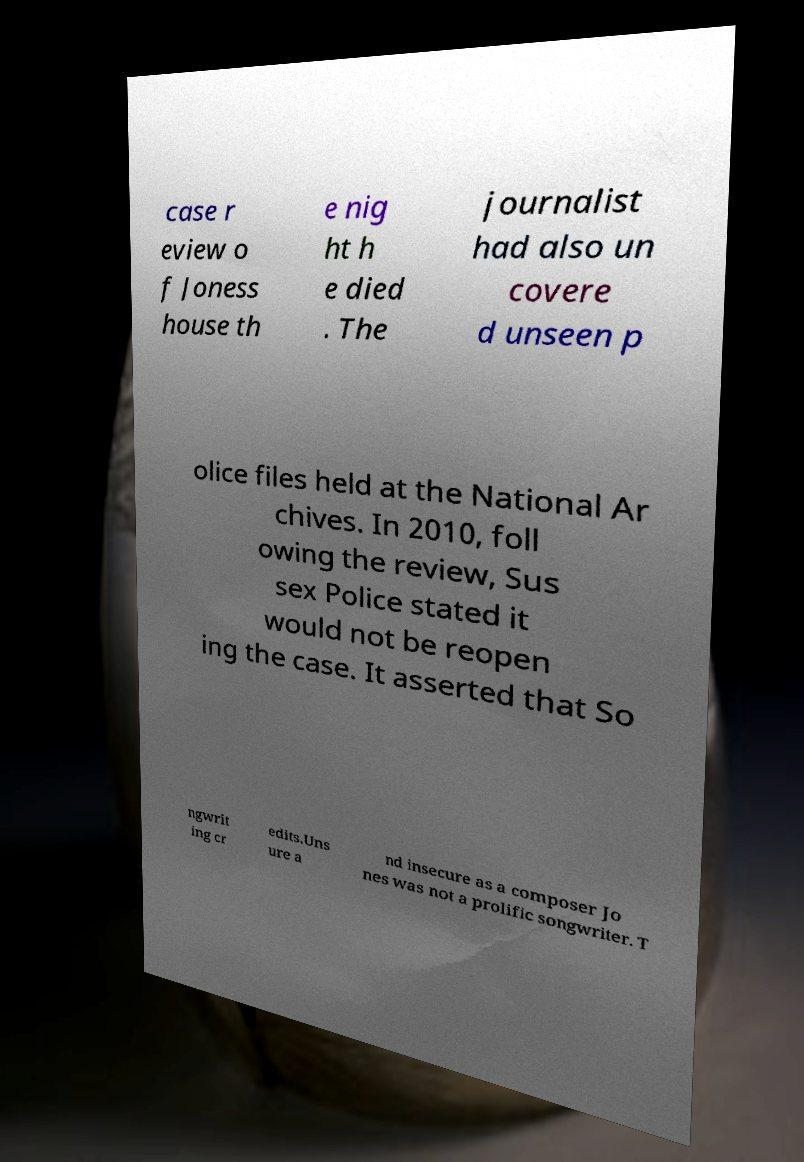Could you extract and type out the text from this image? case r eview o f Joness house th e nig ht h e died . The journalist had also un covere d unseen p olice files held at the National Ar chives. In 2010, foll owing the review, Sus sex Police stated it would not be reopen ing the case. It asserted that So ngwrit ing cr edits.Uns ure a nd insecure as a composer Jo nes was not a prolific songwriter. T 